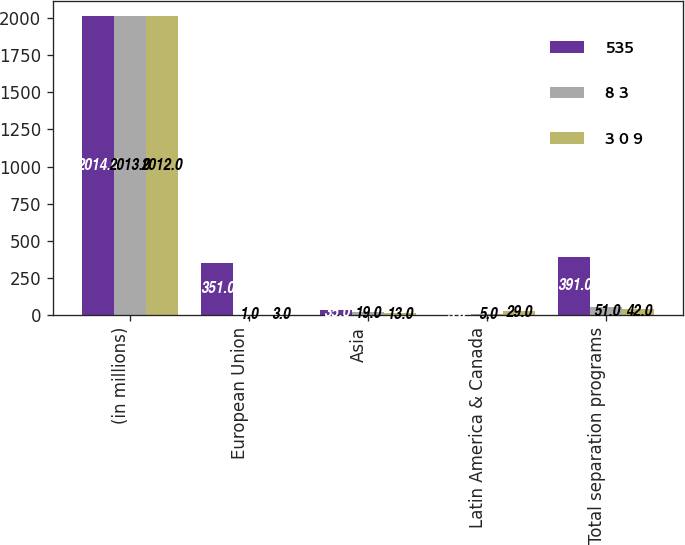Convert chart. <chart><loc_0><loc_0><loc_500><loc_500><stacked_bar_chart><ecel><fcel>(in millions)<fcel>European Union<fcel>Asia<fcel>Latin America & Canada<fcel>Total separation programs<nl><fcel>535<fcel>2014<fcel>351<fcel>35<fcel>3<fcel>391<nl><fcel>8 3<fcel>2013<fcel>1<fcel>19<fcel>5<fcel>51<nl><fcel>3 0 9<fcel>2012<fcel>3<fcel>13<fcel>29<fcel>42<nl></chart> 